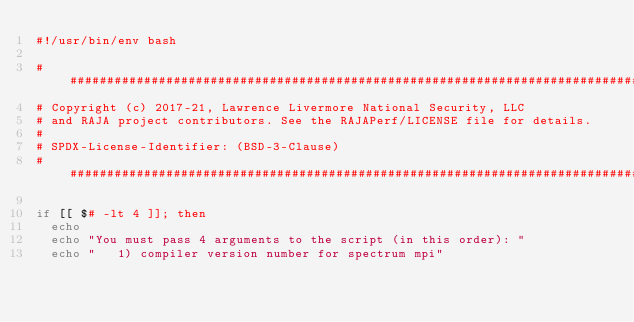Convert code to text. <code><loc_0><loc_0><loc_500><loc_500><_Bash_>#!/usr/bin/env bash

###############################################################################
# Copyright (c) 2017-21, Lawrence Livermore National Security, LLC
# and RAJA project contributors. See the RAJAPerf/LICENSE file for details.
#
# SPDX-License-Identifier: (BSD-3-Clause)
###############################################################################

if [[ $# -lt 4 ]]; then
  echo
  echo "You must pass 4 arguments to the script (in this order): "
  echo "   1) compiler version number for spectrum mpi"</code> 